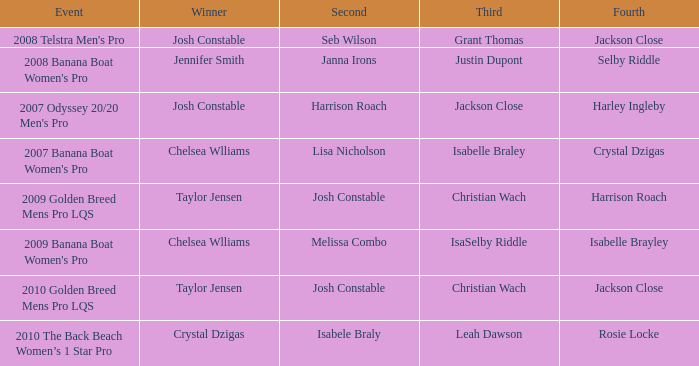Can you parse all the data within this table? {'header': ['Event', 'Winner', 'Second', 'Third', 'Fourth'], 'rows': [["2008 Telstra Men's Pro", 'Josh Constable', 'Seb Wilson', 'Grant Thomas', 'Jackson Close'], ["2008 Banana Boat Women's Pro", 'Jennifer Smith', 'Janna Irons', 'Justin Dupont', 'Selby Riddle'], ["2007 Odyssey 20/20 Men's Pro", 'Josh Constable', 'Harrison Roach', 'Jackson Close', 'Harley Ingleby'], ["2007 Banana Boat Women's Pro", 'Chelsea Wlliams', 'Lisa Nicholson', 'Isabelle Braley', 'Crystal Dzigas'], ['2009 Golden Breed Mens Pro LQS', 'Taylor Jensen', 'Josh Constable', 'Christian Wach', 'Harrison Roach'], ["2009 Banana Boat Women's Pro", 'Chelsea Wlliams', 'Melissa Combo', 'IsaSelby Riddle', 'Isabelle Brayley'], ['2010 Golden Breed Mens Pro LQS', 'Taylor Jensen', 'Josh Constable', 'Christian Wach', 'Jackson Close'], ['2010 The Back Beach Women’s 1 Star Pro', 'Crystal Dzigas', 'Isabele Braly', 'Leah Dawson', 'Rosie Locke']]} Who was in Second Place with Isabelle Brayley came in Fourth? Melissa Combo. 